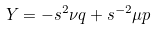Convert formula to latex. <formula><loc_0><loc_0><loc_500><loc_500>Y = - s ^ { 2 } \nu q + s ^ { - 2 } \mu p</formula> 